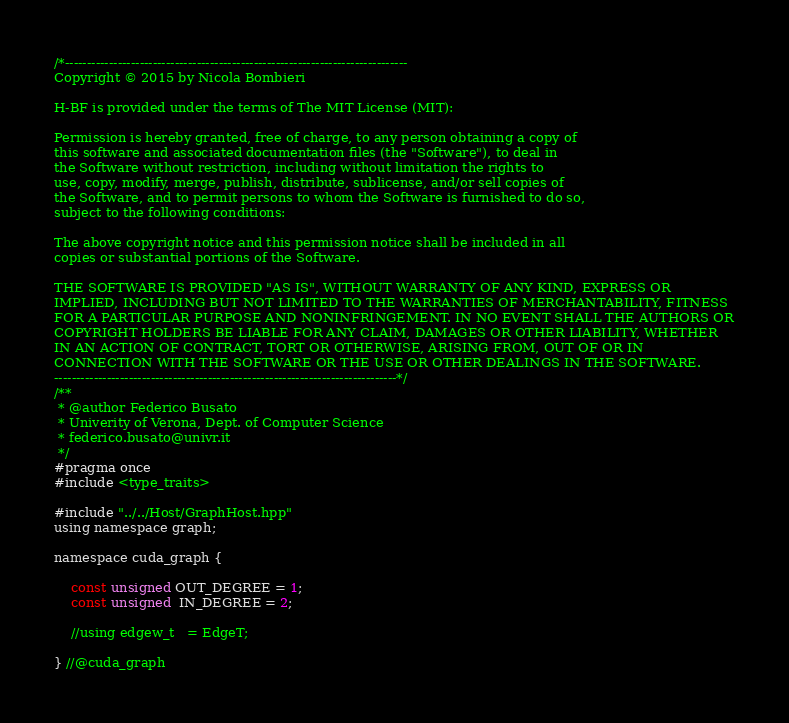<code> <loc_0><loc_0><loc_500><loc_500><_Cuda_>/*------------------------------------------------------------------------------
Copyright © 2015 by Nicola Bombieri

H-BF is provided under the terms of The MIT License (MIT):

Permission is hereby granted, free of charge, to any person obtaining a copy of
this software and associated documentation files (the "Software"), to deal in
the Software without restriction, including without limitation the rights to
use, copy, modify, merge, publish, distribute, sublicense, and/or sell copies of
the Software, and to permit persons to whom the Software is furnished to do so,
subject to the following conditions:

The above copyright notice and this permission notice shall be included in all
copies or substantial portions of the Software.

THE SOFTWARE IS PROVIDED "AS IS", WITHOUT WARRANTY OF ANY KIND, EXPRESS OR
IMPLIED, INCLUDING BUT NOT LIMITED TO THE WARRANTIES OF MERCHANTABILITY, FITNESS
FOR A PARTICULAR PURPOSE AND NONINFRINGEMENT. IN NO EVENT SHALL THE AUTHORS OR
COPYRIGHT HOLDERS BE LIABLE FOR ANY CLAIM, DAMAGES OR OTHER LIABILITY, WHETHER
IN AN ACTION OF CONTRACT, TORT OR OTHERWISE, ARISING FROM, OUT OF OR IN
CONNECTION WITH THE SOFTWARE OR THE USE OR OTHER DEALINGS IN THE SOFTWARE.
------------------------------------------------------------------------------*/
/**
 * @author Federico Busato
 * Univerity of Verona, Dept. of Computer Science
 * federico.busato@univr.it
 */
#pragma once
#include <type_traits>

#include "../../Host/GraphHost.hpp"
using namespace graph;

namespace cuda_graph {

    const unsigned OUT_DEGREE = 1;
    const unsigned  IN_DEGREE = 2;

    //using edgew_t   = EdgeT;

} //@cuda_graph
</code> 